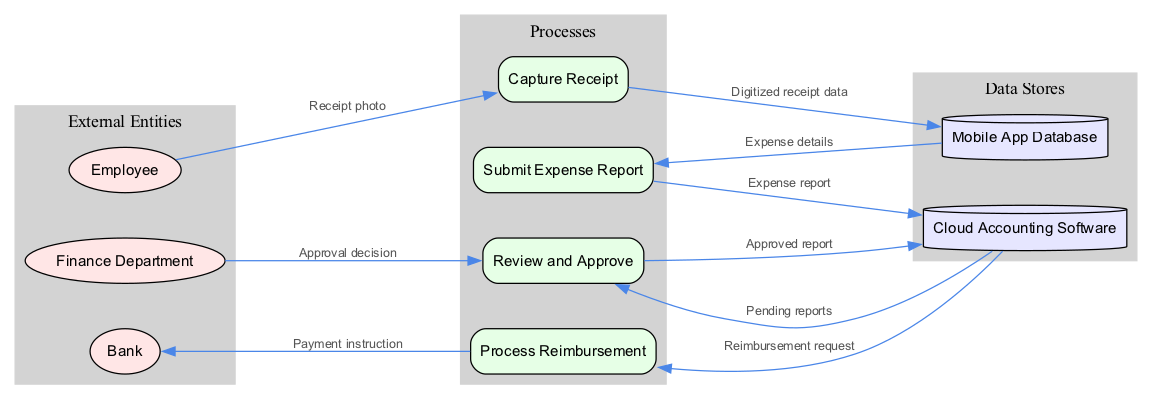What is the first external entity in the diagram? The first external entity listed in the diagram data is "Employee," which corresponds to the first node in the 'External Entities' section.
Answer: Employee How many processes are represented in the diagram? The diagram includes four processes, which are explicitly listed under the 'Processes' section.
Answer: 4 Which node receives the "Receipt photo" data from the Employee? The "Capture Receipt" process is designated to receive the "Receipt photo" from the Employee as per the defined data flow.
Answer: Capture Receipt What is the final node that processes the "Payment instruction"? The "Bank" node is indicated as the final destination for the "Payment instruction" data flowing from the "Process Reimbursement" process.
Answer: Bank What type of node is the "Mobile App Database"? The "Mobile App Database" is categorized as a data store, indicated in the diagram's data store section, which is represented by a cylinder shape.
Answer: Data Store Which process handles the "Approval decision" from the Finance Department? The "Review and Approve" process is responsible for handling the "Approval decision" that flows from the Finance Department.
Answer: Review and Approve What data flows from "Submit Expense Report" to "Cloud Accounting Software"? The data labeled as "Expense report" flows from the "Submit Expense Report" process to the "Cloud Accounting Software," linking these two processes directly.
Answer: Expense report How many data stores are mentioned in the diagram? There are two data stores identified in the diagram: "Cloud Accounting Software" and "Mobile App Database."
Answer: 2 What is the relationship between "Cloud Accounting Software" and "Process Reimbursement"? The "Cloud Accounting Software" sends a "Reimbursement request" to the "Process Reimbursement" process, establishing a directional data flow between these two nodes.
Answer: Reimbursement request 